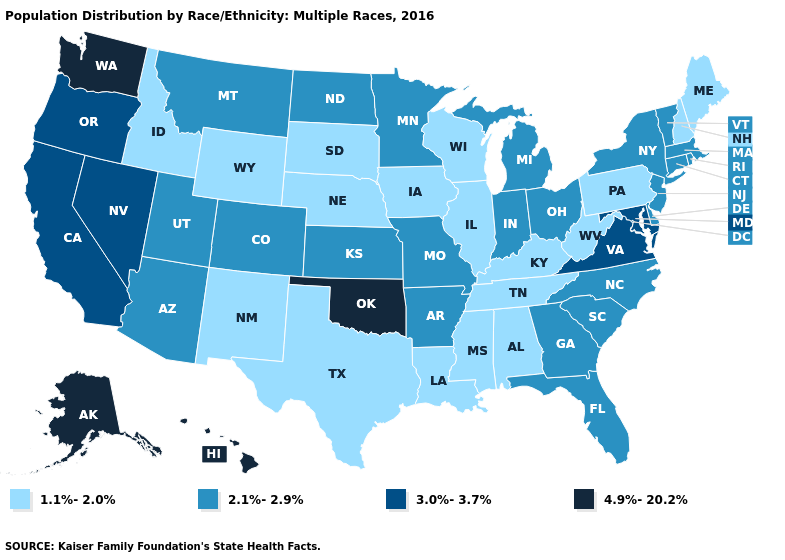Among the states that border California , which have the lowest value?
Write a very short answer. Arizona. What is the value of Maine?
Write a very short answer. 1.1%-2.0%. Does New Hampshire have the highest value in the Northeast?
Be succinct. No. What is the highest value in the West ?
Answer briefly. 4.9%-20.2%. What is the value of Illinois?
Concise answer only. 1.1%-2.0%. Does Nevada have the highest value in the USA?
Be succinct. No. What is the value of Arkansas?
Be succinct. 2.1%-2.9%. What is the lowest value in states that border Montana?
Write a very short answer. 1.1%-2.0%. Name the states that have a value in the range 4.9%-20.2%?
Quick response, please. Alaska, Hawaii, Oklahoma, Washington. Among the states that border Maryland , which have the lowest value?
Concise answer only. Pennsylvania, West Virginia. What is the value of New Mexico?
Be succinct. 1.1%-2.0%. What is the highest value in the USA?
Keep it brief. 4.9%-20.2%. Does Nevada have the highest value in the West?
Quick response, please. No. Name the states that have a value in the range 3.0%-3.7%?
Answer briefly. California, Maryland, Nevada, Oregon, Virginia. What is the value of North Carolina?
Short answer required. 2.1%-2.9%. 